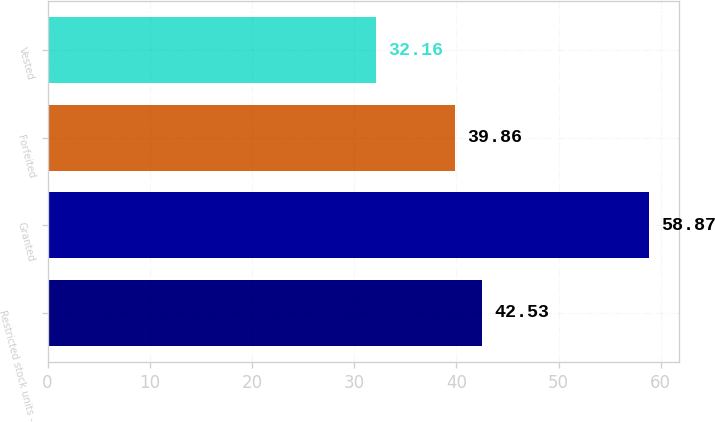<chart> <loc_0><loc_0><loc_500><loc_500><bar_chart><fcel>Restricted stock units -<fcel>Granted<fcel>Forfeited<fcel>Vested<nl><fcel>42.53<fcel>58.87<fcel>39.86<fcel>32.16<nl></chart> 